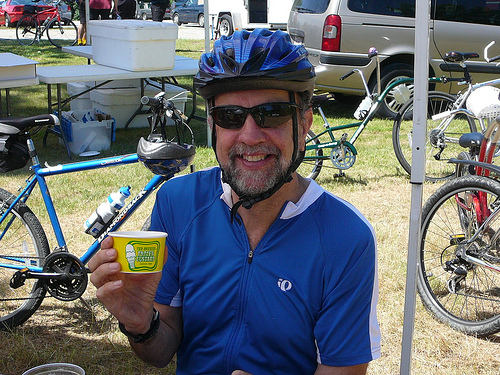What does this image suggest about the person's activity? The image suggests that the person is likely participating in a cycling event or on a leisure cycling trip. The presence of multiple bikes and a setup in the background indicates an organized rest or refreshment area, typical of cycling events. 